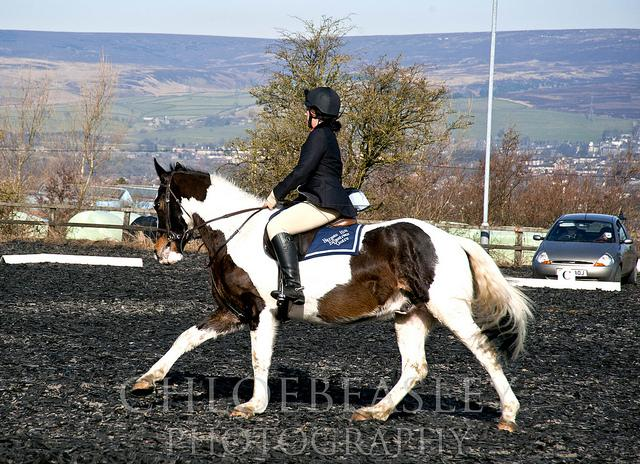What is on top of the horse? Please explain your reasoning. girl. She is the rider obviously. 